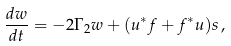<formula> <loc_0><loc_0><loc_500><loc_500>\frac { d w } { d t } = - 2 \Gamma _ { 2 } w + ( u ^ { * } f + f ^ { * } u ) s \, ,</formula> 